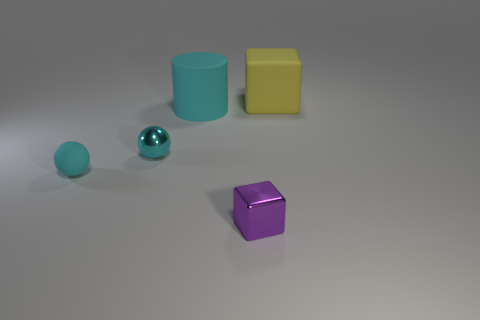Add 3 tiny blue metal cylinders. How many objects exist? 8 Subtract all cylinders. How many objects are left? 4 Subtract 1 cyan cylinders. How many objects are left? 4 Subtract all brown matte objects. Subtract all large rubber cylinders. How many objects are left? 4 Add 3 cyan things. How many cyan things are left? 6 Add 1 tiny purple shiny objects. How many tiny purple shiny objects exist? 2 